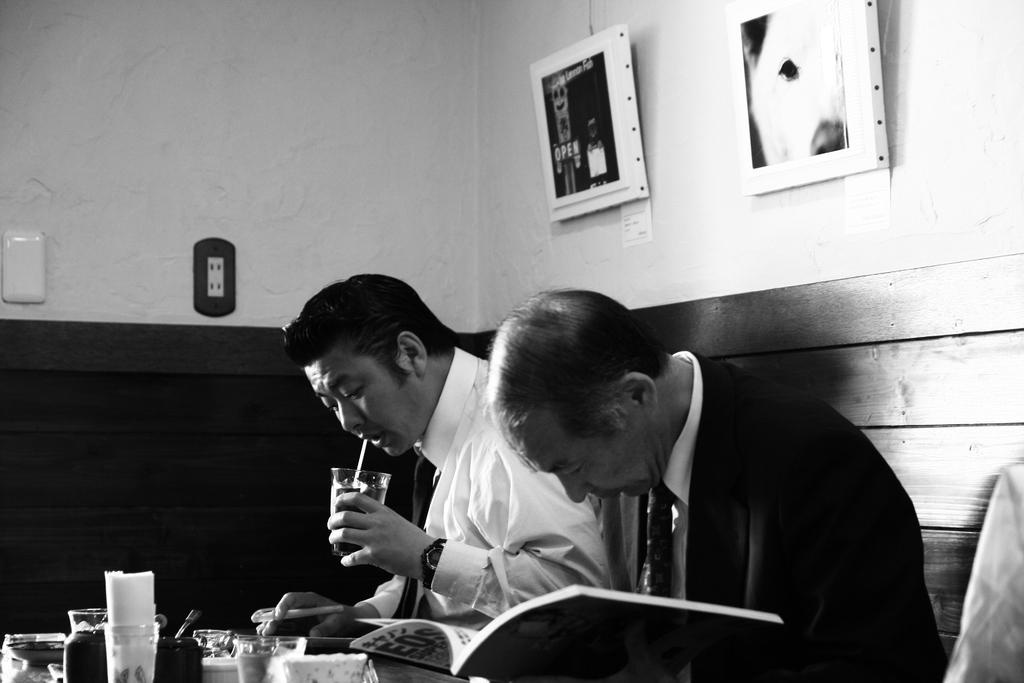How many people are sitting around the table in the image? There are two persons sitting around a table. What can be seen on the table? There are objects on the table. What is visible in the background of the image? There is a wall and photo frames in the background. What type of pump is being used by the father in the image? There is no pump or father present in the image. 